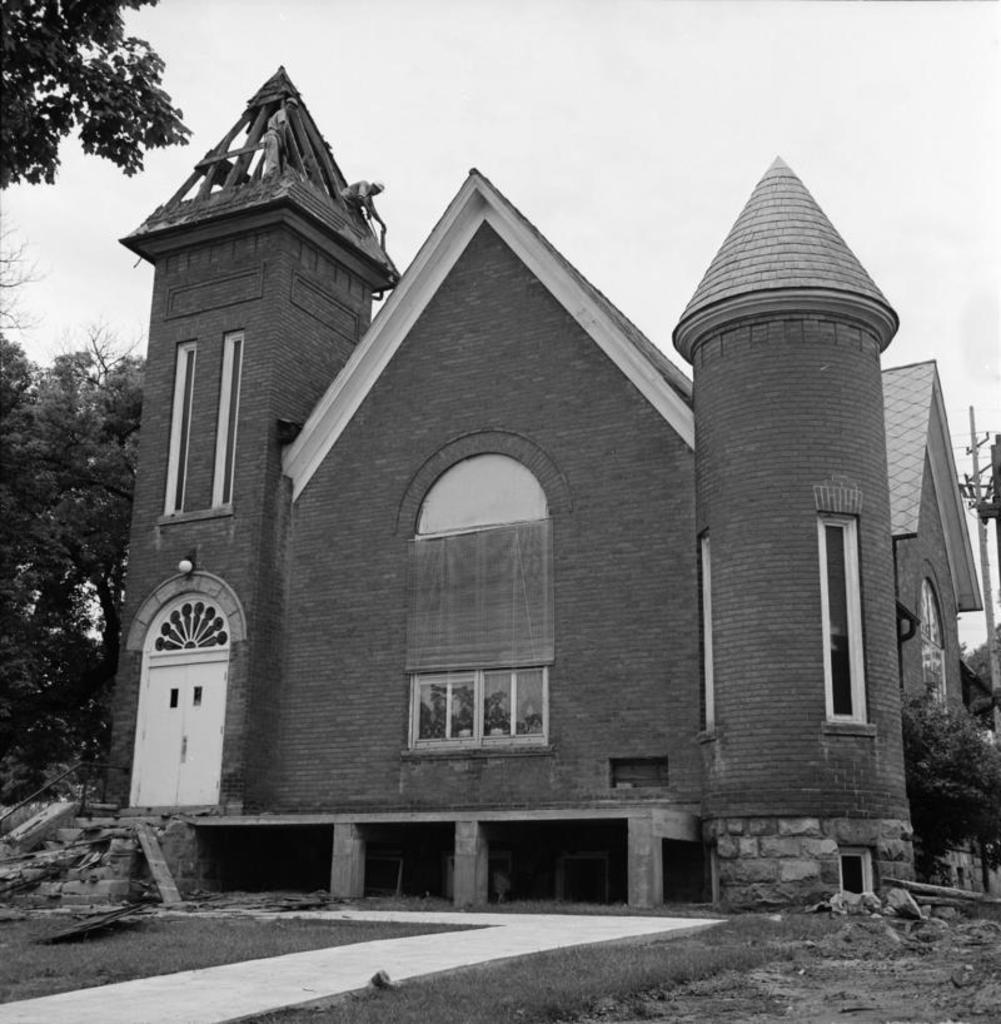Describe this image in one or two sentences. In this image, we can see a house, at the left side there is a some trees, at the top there is a sky. 